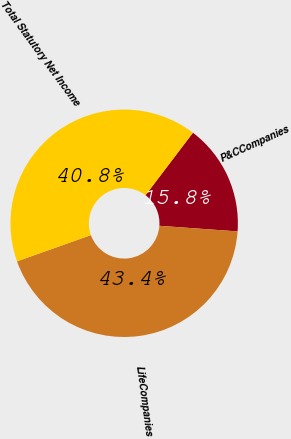Convert chart. <chart><loc_0><loc_0><loc_500><loc_500><pie_chart><fcel>P&CCompanies<fcel>LifeCompanies<fcel>Total Statutory Net Income<nl><fcel>15.8%<fcel>43.43%<fcel>40.77%<nl></chart> 